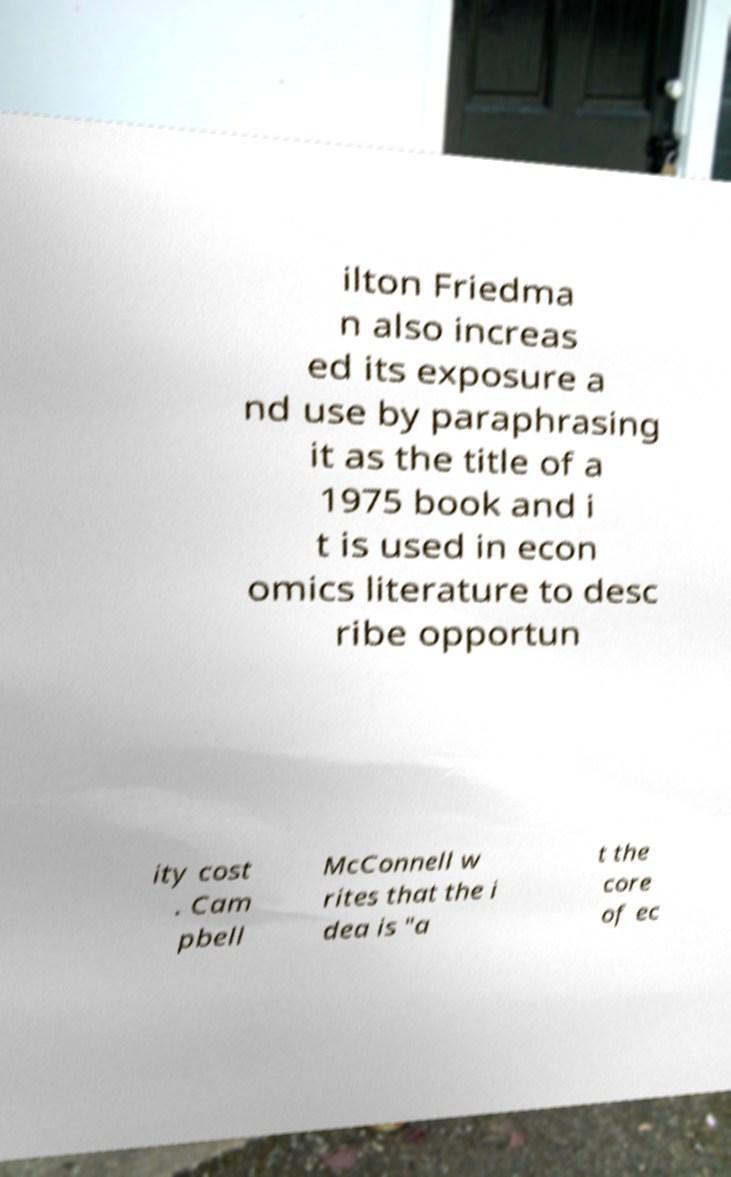I need the written content from this picture converted into text. Can you do that? ilton Friedma n also increas ed its exposure a nd use by paraphrasing it as the title of a 1975 book and i t is used in econ omics literature to desc ribe opportun ity cost . Cam pbell McConnell w rites that the i dea is "a t the core of ec 